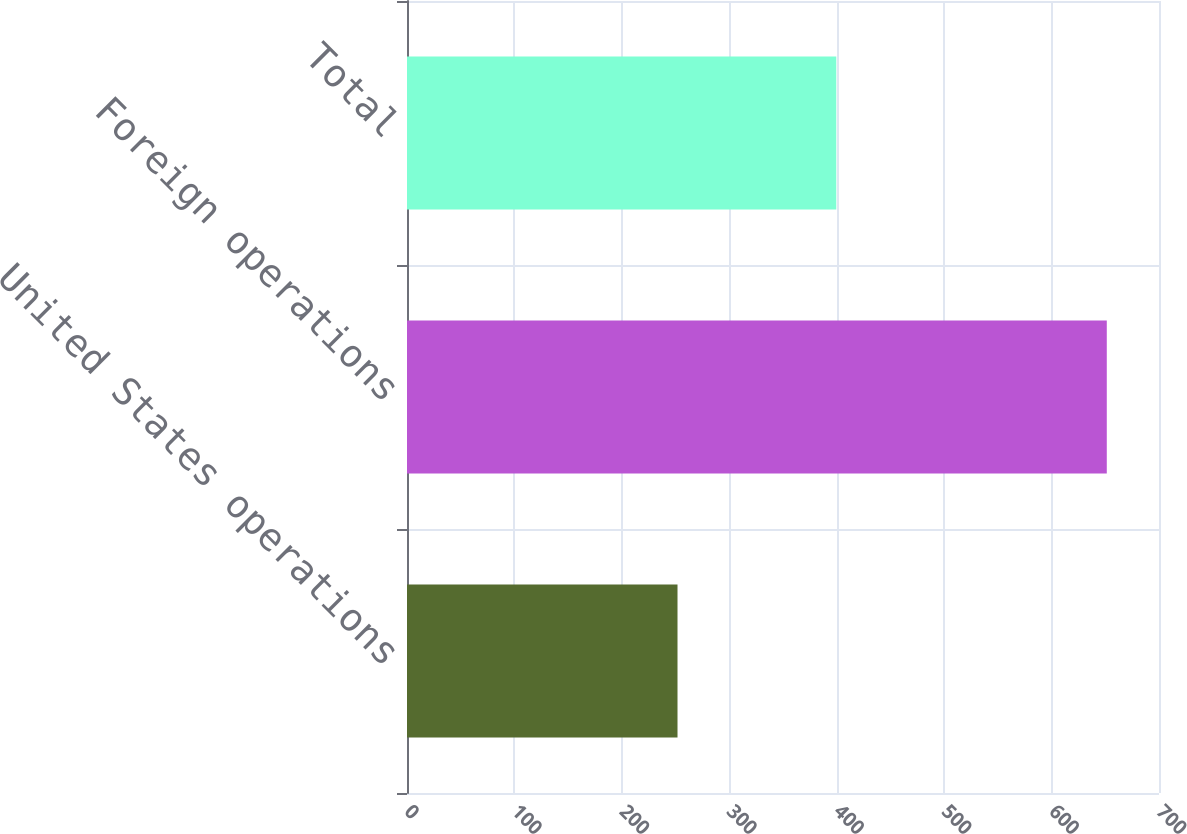Convert chart to OTSL. <chart><loc_0><loc_0><loc_500><loc_500><bar_chart><fcel>United States operations<fcel>Foreign operations<fcel>Total<nl><fcel>251.8<fcel>651.4<fcel>399.6<nl></chart> 